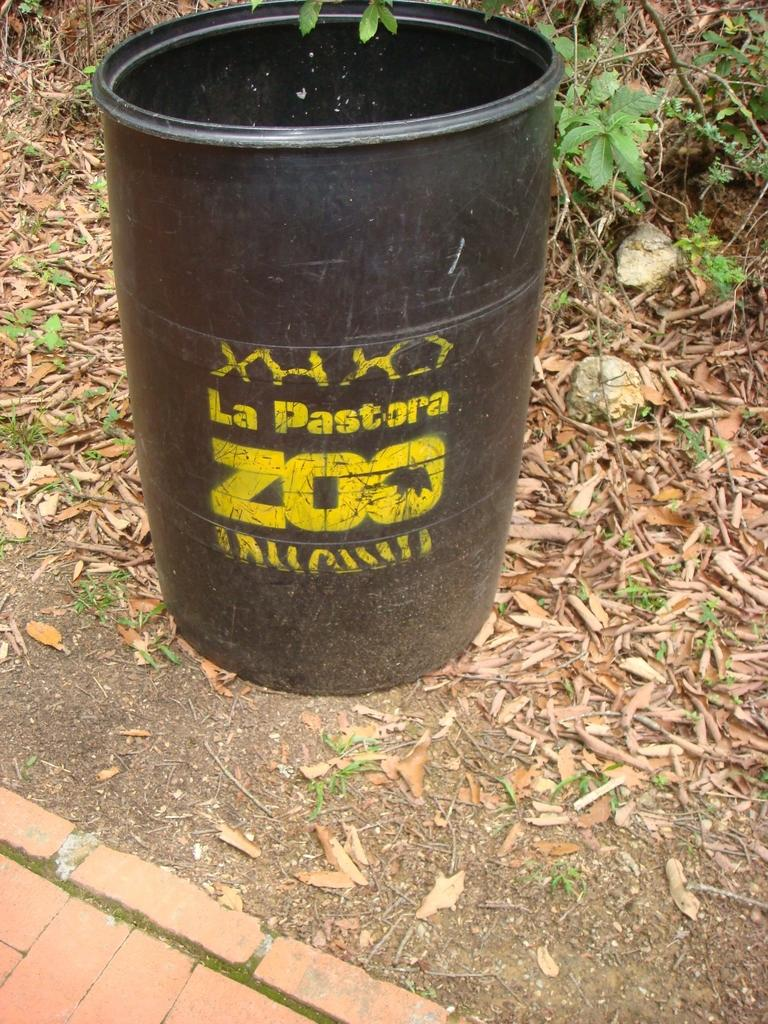<image>
Relay a brief, clear account of the picture shown. An old barrel at the zoo has zebra stripes painted at the bottom. 